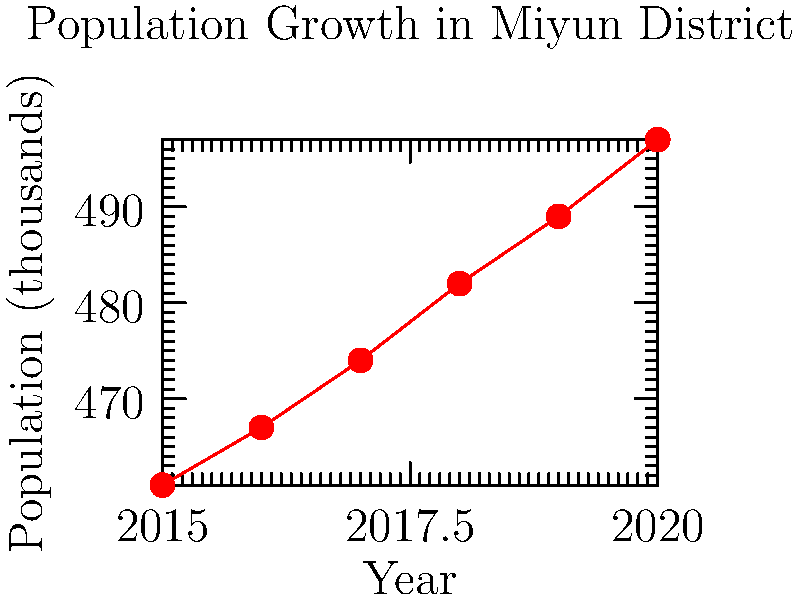Based on the line graph showing the population growth in Miyun District from 2015 to 2020, what is the average annual population increase? How might this trend affect local schools and community services? To find the average annual population increase:

1. Calculate total population increase:
   $497,000 - 461,000 = 36,000$

2. Determine the number of years:
   $2020 - 2015 = 5$ years

3. Calculate average annual increase:
   $36,000 \div 5 = 7,200$ people per year

The trend affects local schools and community services as follows:

1. Schools: An increase of about 7,200 people per year likely includes many children. This could lead to:
   - Increased enrollment in local schools
   - Need for more classrooms and teachers
   - Possible overcrowding if infrastructure doesn't keep pace

2. Community services:
   - Healthcare: Higher demand for medical facilities and professionals
   - Transportation: Increased traffic and need for public transit
   - Utilities: Greater strain on water, electricity, and waste management systems

3. Housing:
   - Increased demand for housing
   - Potential rise in property values and rent prices

4. Economic impact:
   - More consumers for local businesses
   - Increased tax base for the district

As a concerned parent, you should consider how these factors might affect your child's education and quality of life in Miyun District.
Answer: 7,200 people per year; increased demand for schools and community services 